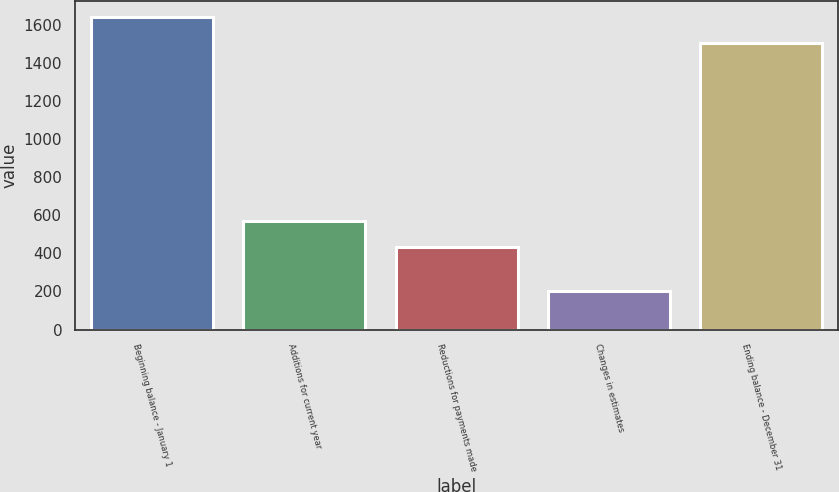Convert chart to OTSL. <chart><loc_0><loc_0><loc_500><loc_500><bar_chart><fcel>Beginning balance - January 1<fcel>Additions for current year<fcel>Reductions for payments made<fcel>Changes in estimates<fcel>Ending balance - December 31<nl><fcel>1641<fcel>569<fcel>432<fcel>200<fcel>1504<nl></chart> 